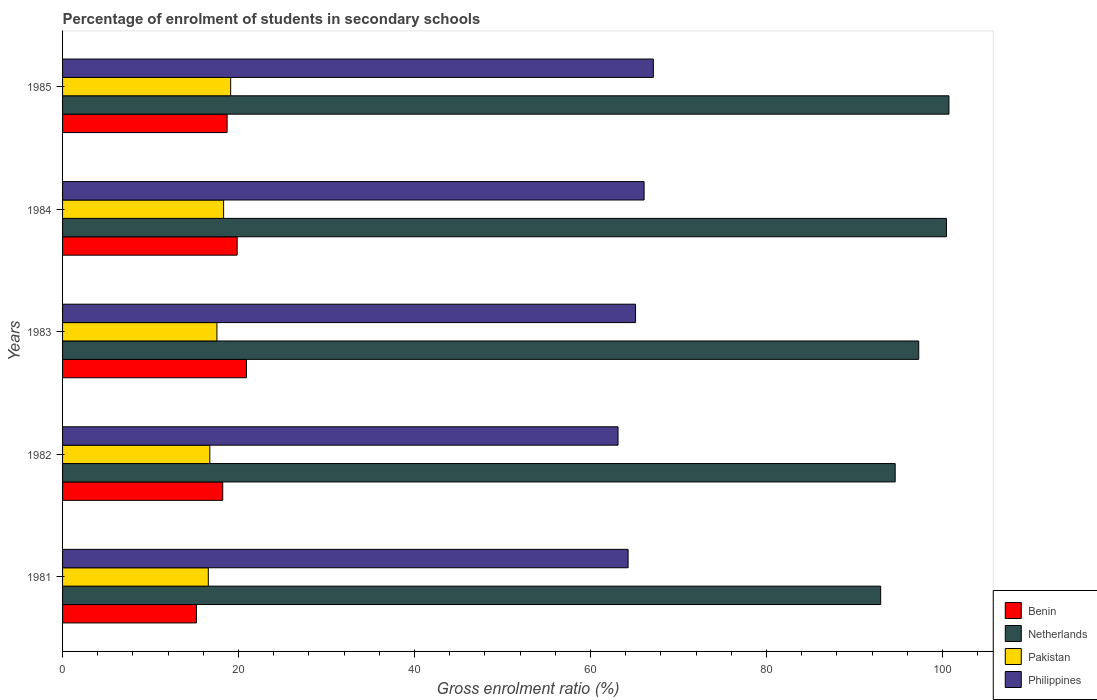Are the number of bars per tick equal to the number of legend labels?
Provide a succinct answer. Yes. How many bars are there on the 4th tick from the top?
Your answer should be very brief. 4. What is the percentage of students enrolled in secondary schools in Netherlands in 1984?
Your response must be concise. 100.45. Across all years, what is the maximum percentage of students enrolled in secondary schools in Pakistan?
Your answer should be very brief. 19.1. Across all years, what is the minimum percentage of students enrolled in secondary schools in Philippines?
Provide a short and direct response. 63.13. What is the total percentage of students enrolled in secondary schools in Benin in the graph?
Offer a terse response. 92.86. What is the difference between the percentage of students enrolled in secondary schools in Philippines in 1984 and that in 1985?
Ensure brevity in your answer.  -1.05. What is the difference between the percentage of students enrolled in secondary schools in Netherlands in 1981 and the percentage of students enrolled in secondary schools in Benin in 1983?
Provide a succinct answer. 72.07. What is the average percentage of students enrolled in secondary schools in Philippines per year?
Give a very brief answer. 65.15. In the year 1982, what is the difference between the percentage of students enrolled in secondary schools in Benin and percentage of students enrolled in secondary schools in Pakistan?
Provide a short and direct response. 1.47. What is the ratio of the percentage of students enrolled in secondary schools in Benin in 1981 to that in 1983?
Offer a terse response. 0.73. Is the difference between the percentage of students enrolled in secondary schools in Benin in 1981 and 1985 greater than the difference between the percentage of students enrolled in secondary schools in Pakistan in 1981 and 1985?
Give a very brief answer. No. What is the difference between the highest and the second highest percentage of students enrolled in secondary schools in Philippines?
Keep it short and to the point. 1.05. What is the difference between the highest and the lowest percentage of students enrolled in secondary schools in Pakistan?
Provide a succinct answer. 2.54. Is the sum of the percentage of students enrolled in secondary schools in Netherlands in 1982 and 1984 greater than the maximum percentage of students enrolled in secondary schools in Benin across all years?
Offer a terse response. Yes. Is it the case that in every year, the sum of the percentage of students enrolled in secondary schools in Netherlands and percentage of students enrolled in secondary schools in Philippines is greater than the sum of percentage of students enrolled in secondary schools in Pakistan and percentage of students enrolled in secondary schools in Benin?
Your response must be concise. Yes. How many years are there in the graph?
Give a very brief answer. 5. Are the values on the major ticks of X-axis written in scientific E-notation?
Keep it short and to the point. No. Does the graph contain grids?
Provide a succinct answer. No. What is the title of the graph?
Give a very brief answer. Percentage of enrolment of students in secondary schools. Does "Swaziland" appear as one of the legend labels in the graph?
Your answer should be very brief. No. What is the Gross enrolment ratio (%) of Benin in 1981?
Your answer should be compact. 15.22. What is the Gross enrolment ratio (%) of Netherlands in 1981?
Make the answer very short. 92.97. What is the Gross enrolment ratio (%) of Pakistan in 1981?
Provide a succinct answer. 16.56. What is the Gross enrolment ratio (%) in Philippines in 1981?
Ensure brevity in your answer.  64.27. What is the Gross enrolment ratio (%) in Benin in 1982?
Ensure brevity in your answer.  18.2. What is the Gross enrolment ratio (%) in Netherlands in 1982?
Provide a succinct answer. 94.62. What is the Gross enrolment ratio (%) in Pakistan in 1982?
Keep it short and to the point. 16.73. What is the Gross enrolment ratio (%) in Philippines in 1982?
Offer a very short reply. 63.13. What is the Gross enrolment ratio (%) in Benin in 1983?
Keep it short and to the point. 20.9. What is the Gross enrolment ratio (%) in Netherlands in 1983?
Offer a terse response. 97.3. What is the Gross enrolment ratio (%) of Pakistan in 1983?
Keep it short and to the point. 17.54. What is the Gross enrolment ratio (%) in Philippines in 1983?
Your response must be concise. 65.12. What is the Gross enrolment ratio (%) in Benin in 1984?
Your answer should be compact. 19.84. What is the Gross enrolment ratio (%) in Netherlands in 1984?
Your response must be concise. 100.45. What is the Gross enrolment ratio (%) in Pakistan in 1984?
Ensure brevity in your answer.  18.3. What is the Gross enrolment ratio (%) in Philippines in 1984?
Your answer should be very brief. 66.09. What is the Gross enrolment ratio (%) of Benin in 1985?
Your response must be concise. 18.7. What is the Gross enrolment ratio (%) in Netherlands in 1985?
Offer a very short reply. 100.73. What is the Gross enrolment ratio (%) of Pakistan in 1985?
Ensure brevity in your answer.  19.1. What is the Gross enrolment ratio (%) of Philippines in 1985?
Your response must be concise. 67.14. Across all years, what is the maximum Gross enrolment ratio (%) in Benin?
Your response must be concise. 20.9. Across all years, what is the maximum Gross enrolment ratio (%) in Netherlands?
Offer a terse response. 100.73. Across all years, what is the maximum Gross enrolment ratio (%) of Pakistan?
Your answer should be very brief. 19.1. Across all years, what is the maximum Gross enrolment ratio (%) in Philippines?
Ensure brevity in your answer.  67.14. Across all years, what is the minimum Gross enrolment ratio (%) in Benin?
Give a very brief answer. 15.22. Across all years, what is the minimum Gross enrolment ratio (%) in Netherlands?
Your answer should be very brief. 92.97. Across all years, what is the minimum Gross enrolment ratio (%) in Pakistan?
Offer a very short reply. 16.56. Across all years, what is the minimum Gross enrolment ratio (%) of Philippines?
Provide a succinct answer. 63.13. What is the total Gross enrolment ratio (%) of Benin in the graph?
Your answer should be compact. 92.86. What is the total Gross enrolment ratio (%) of Netherlands in the graph?
Provide a succinct answer. 486.09. What is the total Gross enrolment ratio (%) of Pakistan in the graph?
Offer a terse response. 88.25. What is the total Gross enrolment ratio (%) of Philippines in the graph?
Your response must be concise. 325.75. What is the difference between the Gross enrolment ratio (%) in Benin in 1981 and that in 1982?
Make the answer very short. -2.98. What is the difference between the Gross enrolment ratio (%) of Netherlands in 1981 and that in 1982?
Give a very brief answer. -1.65. What is the difference between the Gross enrolment ratio (%) in Pakistan in 1981 and that in 1982?
Make the answer very short. -0.17. What is the difference between the Gross enrolment ratio (%) of Philippines in 1981 and that in 1982?
Provide a succinct answer. 1.14. What is the difference between the Gross enrolment ratio (%) of Benin in 1981 and that in 1983?
Provide a short and direct response. -5.68. What is the difference between the Gross enrolment ratio (%) of Netherlands in 1981 and that in 1983?
Provide a succinct answer. -4.33. What is the difference between the Gross enrolment ratio (%) of Pakistan in 1981 and that in 1983?
Offer a very short reply. -0.98. What is the difference between the Gross enrolment ratio (%) in Philippines in 1981 and that in 1983?
Offer a very short reply. -0.85. What is the difference between the Gross enrolment ratio (%) in Benin in 1981 and that in 1984?
Your answer should be very brief. -4.62. What is the difference between the Gross enrolment ratio (%) in Netherlands in 1981 and that in 1984?
Offer a terse response. -7.48. What is the difference between the Gross enrolment ratio (%) in Pakistan in 1981 and that in 1984?
Offer a terse response. -1.74. What is the difference between the Gross enrolment ratio (%) in Philippines in 1981 and that in 1984?
Offer a terse response. -1.82. What is the difference between the Gross enrolment ratio (%) of Benin in 1981 and that in 1985?
Your response must be concise. -3.48. What is the difference between the Gross enrolment ratio (%) of Netherlands in 1981 and that in 1985?
Ensure brevity in your answer.  -7.76. What is the difference between the Gross enrolment ratio (%) in Pakistan in 1981 and that in 1985?
Keep it short and to the point. -2.54. What is the difference between the Gross enrolment ratio (%) in Philippines in 1981 and that in 1985?
Offer a terse response. -2.87. What is the difference between the Gross enrolment ratio (%) of Benin in 1982 and that in 1983?
Ensure brevity in your answer.  -2.7. What is the difference between the Gross enrolment ratio (%) of Netherlands in 1982 and that in 1983?
Provide a short and direct response. -2.68. What is the difference between the Gross enrolment ratio (%) in Pakistan in 1982 and that in 1983?
Your response must be concise. -0.81. What is the difference between the Gross enrolment ratio (%) in Philippines in 1982 and that in 1983?
Your answer should be compact. -1.99. What is the difference between the Gross enrolment ratio (%) of Benin in 1982 and that in 1984?
Provide a succinct answer. -1.64. What is the difference between the Gross enrolment ratio (%) of Netherlands in 1982 and that in 1984?
Offer a very short reply. -5.83. What is the difference between the Gross enrolment ratio (%) of Pakistan in 1982 and that in 1984?
Give a very brief answer. -1.57. What is the difference between the Gross enrolment ratio (%) of Philippines in 1982 and that in 1984?
Provide a succinct answer. -2.96. What is the difference between the Gross enrolment ratio (%) of Benin in 1982 and that in 1985?
Your answer should be very brief. -0.5. What is the difference between the Gross enrolment ratio (%) in Netherlands in 1982 and that in 1985?
Provide a succinct answer. -6.11. What is the difference between the Gross enrolment ratio (%) in Pakistan in 1982 and that in 1985?
Offer a very short reply. -2.37. What is the difference between the Gross enrolment ratio (%) of Philippines in 1982 and that in 1985?
Provide a succinct answer. -4.01. What is the difference between the Gross enrolment ratio (%) of Benin in 1983 and that in 1984?
Provide a short and direct response. 1.06. What is the difference between the Gross enrolment ratio (%) in Netherlands in 1983 and that in 1984?
Your answer should be very brief. -3.15. What is the difference between the Gross enrolment ratio (%) in Pakistan in 1983 and that in 1984?
Offer a terse response. -0.76. What is the difference between the Gross enrolment ratio (%) in Philippines in 1983 and that in 1984?
Offer a terse response. -0.97. What is the difference between the Gross enrolment ratio (%) in Benin in 1983 and that in 1985?
Give a very brief answer. 2.2. What is the difference between the Gross enrolment ratio (%) in Netherlands in 1983 and that in 1985?
Provide a short and direct response. -3.43. What is the difference between the Gross enrolment ratio (%) in Pakistan in 1983 and that in 1985?
Offer a very short reply. -1.56. What is the difference between the Gross enrolment ratio (%) of Philippines in 1983 and that in 1985?
Give a very brief answer. -2.02. What is the difference between the Gross enrolment ratio (%) in Benin in 1984 and that in 1985?
Provide a short and direct response. 1.14. What is the difference between the Gross enrolment ratio (%) of Netherlands in 1984 and that in 1985?
Your answer should be compact. -0.28. What is the difference between the Gross enrolment ratio (%) in Pakistan in 1984 and that in 1985?
Your answer should be very brief. -0.8. What is the difference between the Gross enrolment ratio (%) of Philippines in 1984 and that in 1985?
Keep it short and to the point. -1.05. What is the difference between the Gross enrolment ratio (%) in Benin in 1981 and the Gross enrolment ratio (%) in Netherlands in 1982?
Your answer should be very brief. -79.41. What is the difference between the Gross enrolment ratio (%) in Benin in 1981 and the Gross enrolment ratio (%) in Pakistan in 1982?
Provide a succinct answer. -1.52. What is the difference between the Gross enrolment ratio (%) in Benin in 1981 and the Gross enrolment ratio (%) in Philippines in 1982?
Your response must be concise. -47.91. What is the difference between the Gross enrolment ratio (%) in Netherlands in 1981 and the Gross enrolment ratio (%) in Pakistan in 1982?
Keep it short and to the point. 76.24. What is the difference between the Gross enrolment ratio (%) in Netherlands in 1981 and the Gross enrolment ratio (%) in Philippines in 1982?
Your response must be concise. 29.85. What is the difference between the Gross enrolment ratio (%) of Pakistan in 1981 and the Gross enrolment ratio (%) of Philippines in 1982?
Offer a very short reply. -46.56. What is the difference between the Gross enrolment ratio (%) of Benin in 1981 and the Gross enrolment ratio (%) of Netherlands in 1983?
Keep it short and to the point. -82.08. What is the difference between the Gross enrolment ratio (%) of Benin in 1981 and the Gross enrolment ratio (%) of Pakistan in 1983?
Give a very brief answer. -2.32. What is the difference between the Gross enrolment ratio (%) in Benin in 1981 and the Gross enrolment ratio (%) in Philippines in 1983?
Ensure brevity in your answer.  -49.9. What is the difference between the Gross enrolment ratio (%) of Netherlands in 1981 and the Gross enrolment ratio (%) of Pakistan in 1983?
Give a very brief answer. 75.43. What is the difference between the Gross enrolment ratio (%) in Netherlands in 1981 and the Gross enrolment ratio (%) in Philippines in 1983?
Ensure brevity in your answer.  27.86. What is the difference between the Gross enrolment ratio (%) of Pakistan in 1981 and the Gross enrolment ratio (%) of Philippines in 1983?
Ensure brevity in your answer.  -48.55. What is the difference between the Gross enrolment ratio (%) in Benin in 1981 and the Gross enrolment ratio (%) in Netherlands in 1984?
Provide a short and direct response. -85.24. What is the difference between the Gross enrolment ratio (%) of Benin in 1981 and the Gross enrolment ratio (%) of Pakistan in 1984?
Provide a short and direct response. -3.08. What is the difference between the Gross enrolment ratio (%) of Benin in 1981 and the Gross enrolment ratio (%) of Philippines in 1984?
Provide a short and direct response. -50.87. What is the difference between the Gross enrolment ratio (%) in Netherlands in 1981 and the Gross enrolment ratio (%) in Pakistan in 1984?
Offer a very short reply. 74.67. What is the difference between the Gross enrolment ratio (%) in Netherlands in 1981 and the Gross enrolment ratio (%) in Philippines in 1984?
Offer a very short reply. 26.89. What is the difference between the Gross enrolment ratio (%) in Pakistan in 1981 and the Gross enrolment ratio (%) in Philippines in 1984?
Make the answer very short. -49.52. What is the difference between the Gross enrolment ratio (%) in Benin in 1981 and the Gross enrolment ratio (%) in Netherlands in 1985?
Make the answer very short. -85.52. What is the difference between the Gross enrolment ratio (%) of Benin in 1981 and the Gross enrolment ratio (%) of Pakistan in 1985?
Make the answer very short. -3.89. What is the difference between the Gross enrolment ratio (%) of Benin in 1981 and the Gross enrolment ratio (%) of Philippines in 1985?
Ensure brevity in your answer.  -51.92. What is the difference between the Gross enrolment ratio (%) in Netherlands in 1981 and the Gross enrolment ratio (%) in Pakistan in 1985?
Ensure brevity in your answer.  73.87. What is the difference between the Gross enrolment ratio (%) in Netherlands in 1981 and the Gross enrolment ratio (%) in Philippines in 1985?
Offer a terse response. 25.83. What is the difference between the Gross enrolment ratio (%) in Pakistan in 1981 and the Gross enrolment ratio (%) in Philippines in 1985?
Ensure brevity in your answer.  -50.58. What is the difference between the Gross enrolment ratio (%) in Benin in 1982 and the Gross enrolment ratio (%) in Netherlands in 1983?
Your response must be concise. -79.1. What is the difference between the Gross enrolment ratio (%) in Benin in 1982 and the Gross enrolment ratio (%) in Pakistan in 1983?
Offer a very short reply. 0.66. What is the difference between the Gross enrolment ratio (%) in Benin in 1982 and the Gross enrolment ratio (%) in Philippines in 1983?
Your answer should be compact. -46.91. What is the difference between the Gross enrolment ratio (%) of Netherlands in 1982 and the Gross enrolment ratio (%) of Pakistan in 1983?
Your answer should be compact. 77.08. What is the difference between the Gross enrolment ratio (%) of Netherlands in 1982 and the Gross enrolment ratio (%) of Philippines in 1983?
Give a very brief answer. 29.51. What is the difference between the Gross enrolment ratio (%) of Pakistan in 1982 and the Gross enrolment ratio (%) of Philippines in 1983?
Your response must be concise. -48.38. What is the difference between the Gross enrolment ratio (%) of Benin in 1982 and the Gross enrolment ratio (%) of Netherlands in 1984?
Offer a very short reply. -82.25. What is the difference between the Gross enrolment ratio (%) of Benin in 1982 and the Gross enrolment ratio (%) of Pakistan in 1984?
Your answer should be very brief. -0.1. What is the difference between the Gross enrolment ratio (%) of Benin in 1982 and the Gross enrolment ratio (%) of Philippines in 1984?
Give a very brief answer. -47.89. What is the difference between the Gross enrolment ratio (%) of Netherlands in 1982 and the Gross enrolment ratio (%) of Pakistan in 1984?
Give a very brief answer. 76.32. What is the difference between the Gross enrolment ratio (%) in Netherlands in 1982 and the Gross enrolment ratio (%) in Philippines in 1984?
Keep it short and to the point. 28.54. What is the difference between the Gross enrolment ratio (%) in Pakistan in 1982 and the Gross enrolment ratio (%) in Philippines in 1984?
Give a very brief answer. -49.35. What is the difference between the Gross enrolment ratio (%) of Benin in 1982 and the Gross enrolment ratio (%) of Netherlands in 1985?
Your response must be concise. -82.53. What is the difference between the Gross enrolment ratio (%) of Benin in 1982 and the Gross enrolment ratio (%) of Pakistan in 1985?
Offer a very short reply. -0.9. What is the difference between the Gross enrolment ratio (%) of Benin in 1982 and the Gross enrolment ratio (%) of Philippines in 1985?
Ensure brevity in your answer.  -48.94. What is the difference between the Gross enrolment ratio (%) of Netherlands in 1982 and the Gross enrolment ratio (%) of Pakistan in 1985?
Ensure brevity in your answer.  75.52. What is the difference between the Gross enrolment ratio (%) of Netherlands in 1982 and the Gross enrolment ratio (%) of Philippines in 1985?
Provide a succinct answer. 27.48. What is the difference between the Gross enrolment ratio (%) in Pakistan in 1982 and the Gross enrolment ratio (%) in Philippines in 1985?
Offer a very short reply. -50.41. What is the difference between the Gross enrolment ratio (%) in Benin in 1983 and the Gross enrolment ratio (%) in Netherlands in 1984?
Provide a short and direct response. -79.55. What is the difference between the Gross enrolment ratio (%) in Benin in 1983 and the Gross enrolment ratio (%) in Pakistan in 1984?
Offer a terse response. 2.6. What is the difference between the Gross enrolment ratio (%) in Benin in 1983 and the Gross enrolment ratio (%) in Philippines in 1984?
Your answer should be compact. -45.19. What is the difference between the Gross enrolment ratio (%) in Netherlands in 1983 and the Gross enrolment ratio (%) in Pakistan in 1984?
Give a very brief answer. 79. What is the difference between the Gross enrolment ratio (%) of Netherlands in 1983 and the Gross enrolment ratio (%) of Philippines in 1984?
Your response must be concise. 31.21. What is the difference between the Gross enrolment ratio (%) in Pakistan in 1983 and the Gross enrolment ratio (%) in Philippines in 1984?
Give a very brief answer. -48.55. What is the difference between the Gross enrolment ratio (%) in Benin in 1983 and the Gross enrolment ratio (%) in Netherlands in 1985?
Offer a terse response. -79.83. What is the difference between the Gross enrolment ratio (%) in Benin in 1983 and the Gross enrolment ratio (%) in Pakistan in 1985?
Offer a terse response. 1.8. What is the difference between the Gross enrolment ratio (%) of Benin in 1983 and the Gross enrolment ratio (%) of Philippines in 1985?
Your response must be concise. -46.24. What is the difference between the Gross enrolment ratio (%) in Netherlands in 1983 and the Gross enrolment ratio (%) in Pakistan in 1985?
Offer a very short reply. 78.2. What is the difference between the Gross enrolment ratio (%) of Netherlands in 1983 and the Gross enrolment ratio (%) of Philippines in 1985?
Offer a terse response. 30.16. What is the difference between the Gross enrolment ratio (%) of Pakistan in 1983 and the Gross enrolment ratio (%) of Philippines in 1985?
Your answer should be compact. -49.6. What is the difference between the Gross enrolment ratio (%) in Benin in 1984 and the Gross enrolment ratio (%) in Netherlands in 1985?
Give a very brief answer. -80.89. What is the difference between the Gross enrolment ratio (%) of Benin in 1984 and the Gross enrolment ratio (%) of Pakistan in 1985?
Your answer should be very brief. 0.74. What is the difference between the Gross enrolment ratio (%) in Benin in 1984 and the Gross enrolment ratio (%) in Philippines in 1985?
Your answer should be compact. -47.3. What is the difference between the Gross enrolment ratio (%) of Netherlands in 1984 and the Gross enrolment ratio (%) of Pakistan in 1985?
Offer a terse response. 81.35. What is the difference between the Gross enrolment ratio (%) of Netherlands in 1984 and the Gross enrolment ratio (%) of Philippines in 1985?
Offer a very short reply. 33.31. What is the difference between the Gross enrolment ratio (%) in Pakistan in 1984 and the Gross enrolment ratio (%) in Philippines in 1985?
Ensure brevity in your answer.  -48.84. What is the average Gross enrolment ratio (%) of Benin per year?
Provide a short and direct response. 18.57. What is the average Gross enrolment ratio (%) of Netherlands per year?
Offer a very short reply. 97.22. What is the average Gross enrolment ratio (%) of Pakistan per year?
Keep it short and to the point. 17.65. What is the average Gross enrolment ratio (%) in Philippines per year?
Your answer should be very brief. 65.15. In the year 1981, what is the difference between the Gross enrolment ratio (%) of Benin and Gross enrolment ratio (%) of Netherlands?
Give a very brief answer. -77.76. In the year 1981, what is the difference between the Gross enrolment ratio (%) of Benin and Gross enrolment ratio (%) of Pakistan?
Your response must be concise. -1.35. In the year 1981, what is the difference between the Gross enrolment ratio (%) of Benin and Gross enrolment ratio (%) of Philippines?
Your answer should be very brief. -49.05. In the year 1981, what is the difference between the Gross enrolment ratio (%) in Netherlands and Gross enrolment ratio (%) in Pakistan?
Make the answer very short. 76.41. In the year 1981, what is the difference between the Gross enrolment ratio (%) in Netherlands and Gross enrolment ratio (%) in Philippines?
Keep it short and to the point. 28.7. In the year 1981, what is the difference between the Gross enrolment ratio (%) in Pakistan and Gross enrolment ratio (%) in Philippines?
Ensure brevity in your answer.  -47.71. In the year 1982, what is the difference between the Gross enrolment ratio (%) of Benin and Gross enrolment ratio (%) of Netherlands?
Make the answer very short. -76.42. In the year 1982, what is the difference between the Gross enrolment ratio (%) in Benin and Gross enrolment ratio (%) in Pakistan?
Offer a very short reply. 1.47. In the year 1982, what is the difference between the Gross enrolment ratio (%) in Benin and Gross enrolment ratio (%) in Philippines?
Keep it short and to the point. -44.92. In the year 1982, what is the difference between the Gross enrolment ratio (%) in Netherlands and Gross enrolment ratio (%) in Pakistan?
Ensure brevity in your answer.  77.89. In the year 1982, what is the difference between the Gross enrolment ratio (%) in Netherlands and Gross enrolment ratio (%) in Philippines?
Provide a short and direct response. 31.5. In the year 1982, what is the difference between the Gross enrolment ratio (%) of Pakistan and Gross enrolment ratio (%) of Philippines?
Give a very brief answer. -46.39. In the year 1983, what is the difference between the Gross enrolment ratio (%) of Benin and Gross enrolment ratio (%) of Netherlands?
Provide a succinct answer. -76.4. In the year 1983, what is the difference between the Gross enrolment ratio (%) of Benin and Gross enrolment ratio (%) of Pakistan?
Make the answer very short. 3.36. In the year 1983, what is the difference between the Gross enrolment ratio (%) of Benin and Gross enrolment ratio (%) of Philippines?
Your answer should be very brief. -44.22. In the year 1983, what is the difference between the Gross enrolment ratio (%) of Netherlands and Gross enrolment ratio (%) of Pakistan?
Ensure brevity in your answer.  79.76. In the year 1983, what is the difference between the Gross enrolment ratio (%) in Netherlands and Gross enrolment ratio (%) in Philippines?
Provide a short and direct response. 32.18. In the year 1983, what is the difference between the Gross enrolment ratio (%) of Pakistan and Gross enrolment ratio (%) of Philippines?
Provide a succinct answer. -47.57. In the year 1984, what is the difference between the Gross enrolment ratio (%) in Benin and Gross enrolment ratio (%) in Netherlands?
Ensure brevity in your answer.  -80.61. In the year 1984, what is the difference between the Gross enrolment ratio (%) in Benin and Gross enrolment ratio (%) in Pakistan?
Provide a short and direct response. 1.54. In the year 1984, what is the difference between the Gross enrolment ratio (%) in Benin and Gross enrolment ratio (%) in Philippines?
Your answer should be very brief. -46.25. In the year 1984, what is the difference between the Gross enrolment ratio (%) in Netherlands and Gross enrolment ratio (%) in Pakistan?
Offer a very short reply. 82.15. In the year 1984, what is the difference between the Gross enrolment ratio (%) of Netherlands and Gross enrolment ratio (%) of Philippines?
Provide a short and direct response. 34.36. In the year 1984, what is the difference between the Gross enrolment ratio (%) of Pakistan and Gross enrolment ratio (%) of Philippines?
Give a very brief answer. -47.79. In the year 1985, what is the difference between the Gross enrolment ratio (%) in Benin and Gross enrolment ratio (%) in Netherlands?
Your answer should be very brief. -82.03. In the year 1985, what is the difference between the Gross enrolment ratio (%) in Benin and Gross enrolment ratio (%) in Pakistan?
Your response must be concise. -0.4. In the year 1985, what is the difference between the Gross enrolment ratio (%) of Benin and Gross enrolment ratio (%) of Philippines?
Provide a succinct answer. -48.44. In the year 1985, what is the difference between the Gross enrolment ratio (%) in Netherlands and Gross enrolment ratio (%) in Pakistan?
Provide a short and direct response. 81.63. In the year 1985, what is the difference between the Gross enrolment ratio (%) in Netherlands and Gross enrolment ratio (%) in Philippines?
Your response must be concise. 33.59. In the year 1985, what is the difference between the Gross enrolment ratio (%) in Pakistan and Gross enrolment ratio (%) in Philippines?
Your response must be concise. -48.04. What is the ratio of the Gross enrolment ratio (%) of Benin in 1981 to that in 1982?
Your answer should be very brief. 0.84. What is the ratio of the Gross enrolment ratio (%) in Netherlands in 1981 to that in 1982?
Ensure brevity in your answer.  0.98. What is the ratio of the Gross enrolment ratio (%) of Philippines in 1981 to that in 1982?
Offer a terse response. 1.02. What is the ratio of the Gross enrolment ratio (%) in Benin in 1981 to that in 1983?
Offer a very short reply. 0.73. What is the ratio of the Gross enrolment ratio (%) in Netherlands in 1981 to that in 1983?
Make the answer very short. 0.96. What is the ratio of the Gross enrolment ratio (%) in Pakistan in 1981 to that in 1983?
Make the answer very short. 0.94. What is the ratio of the Gross enrolment ratio (%) in Philippines in 1981 to that in 1983?
Keep it short and to the point. 0.99. What is the ratio of the Gross enrolment ratio (%) of Benin in 1981 to that in 1984?
Provide a short and direct response. 0.77. What is the ratio of the Gross enrolment ratio (%) of Netherlands in 1981 to that in 1984?
Make the answer very short. 0.93. What is the ratio of the Gross enrolment ratio (%) of Pakistan in 1981 to that in 1984?
Make the answer very short. 0.91. What is the ratio of the Gross enrolment ratio (%) in Philippines in 1981 to that in 1984?
Give a very brief answer. 0.97. What is the ratio of the Gross enrolment ratio (%) of Benin in 1981 to that in 1985?
Offer a very short reply. 0.81. What is the ratio of the Gross enrolment ratio (%) in Netherlands in 1981 to that in 1985?
Provide a short and direct response. 0.92. What is the ratio of the Gross enrolment ratio (%) in Pakistan in 1981 to that in 1985?
Offer a terse response. 0.87. What is the ratio of the Gross enrolment ratio (%) of Philippines in 1981 to that in 1985?
Keep it short and to the point. 0.96. What is the ratio of the Gross enrolment ratio (%) in Benin in 1982 to that in 1983?
Provide a succinct answer. 0.87. What is the ratio of the Gross enrolment ratio (%) of Netherlands in 1982 to that in 1983?
Ensure brevity in your answer.  0.97. What is the ratio of the Gross enrolment ratio (%) in Pakistan in 1982 to that in 1983?
Give a very brief answer. 0.95. What is the ratio of the Gross enrolment ratio (%) of Philippines in 1982 to that in 1983?
Provide a short and direct response. 0.97. What is the ratio of the Gross enrolment ratio (%) of Benin in 1982 to that in 1984?
Provide a short and direct response. 0.92. What is the ratio of the Gross enrolment ratio (%) in Netherlands in 1982 to that in 1984?
Your answer should be very brief. 0.94. What is the ratio of the Gross enrolment ratio (%) of Pakistan in 1982 to that in 1984?
Make the answer very short. 0.91. What is the ratio of the Gross enrolment ratio (%) of Philippines in 1982 to that in 1984?
Keep it short and to the point. 0.96. What is the ratio of the Gross enrolment ratio (%) of Benin in 1982 to that in 1985?
Keep it short and to the point. 0.97. What is the ratio of the Gross enrolment ratio (%) in Netherlands in 1982 to that in 1985?
Provide a succinct answer. 0.94. What is the ratio of the Gross enrolment ratio (%) in Pakistan in 1982 to that in 1985?
Give a very brief answer. 0.88. What is the ratio of the Gross enrolment ratio (%) in Philippines in 1982 to that in 1985?
Keep it short and to the point. 0.94. What is the ratio of the Gross enrolment ratio (%) of Benin in 1983 to that in 1984?
Your response must be concise. 1.05. What is the ratio of the Gross enrolment ratio (%) in Netherlands in 1983 to that in 1984?
Your response must be concise. 0.97. What is the ratio of the Gross enrolment ratio (%) in Pakistan in 1983 to that in 1984?
Make the answer very short. 0.96. What is the ratio of the Gross enrolment ratio (%) in Benin in 1983 to that in 1985?
Keep it short and to the point. 1.12. What is the ratio of the Gross enrolment ratio (%) in Netherlands in 1983 to that in 1985?
Your answer should be compact. 0.97. What is the ratio of the Gross enrolment ratio (%) of Pakistan in 1983 to that in 1985?
Give a very brief answer. 0.92. What is the ratio of the Gross enrolment ratio (%) in Philippines in 1983 to that in 1985?
Make the answer very short. 0.97. What is the ratio of the Gross enrolment ratio (%) of Benin in 1984 to that in 1985?
Your answer should be compact. 1.06. What is the ratio of the Gross enrolment ratio (%) in Netherlands in 1984 to that in 1985?
Offer a very short reply. 1. What is the ratio of the Gross enrolment ratio (%) in Pakistan in 1984 to that in 1985?
Make the answer very short. 0.96. What is the ratio of the Gross enrolment ratio (%) in Philippines in 1984 to that in 1985?
Offer a very short reply. 0.98. What is the difference between the highest and the second highest Gross enrolment ratio (%) in Benin?
Your answer should be very brief. 1.06. What is the difference between the highest and the second highest Gross enrolment ratio (%) of Netherlands?
Provide a succinct answer. 0.28. What is the difference between the highest and the second highest Gross enrolment ratio (%) of Pakistan?
Offer a terse response. 0.8. What is the difference between the highest and the second highest Gross enrolment ratio (%) of Philippines?
Your answer should be very brief. 1.05. What is the difference between the highest and the lowest Gross enrolment ratio (%) in Benin?
Your answer should be very brief. 5.68. What is the difference between the highest and the lowest Gross enrolment ratio (%) in Netherlands?
Provide a succinct answer. 7.76. What is the difference between the highest and the lowest Gross enrolment ratio (%) in Pakistan?
Keep it short and to the point. 2.54. What is the difference between the highest and the lowest Gross enrolment ratio (%) of Philippines?
Your answer should be very brief. 4.01. 